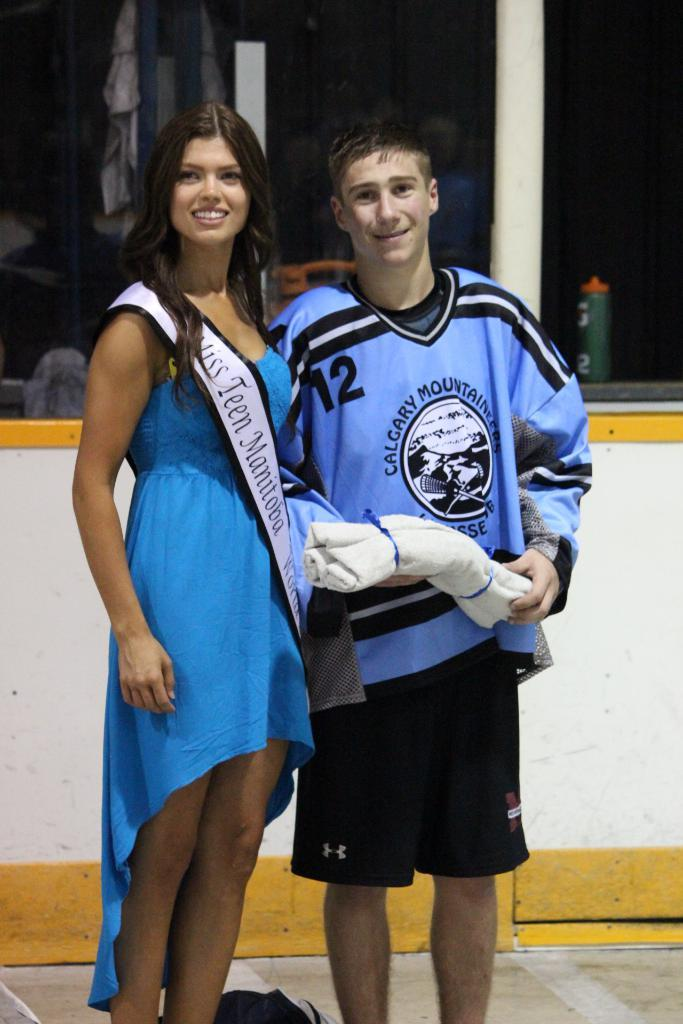<image>
Summarize the visual content of the image. A girl in a blue dress that says Miss Teen Manitoba is standing next to a hockey player. 